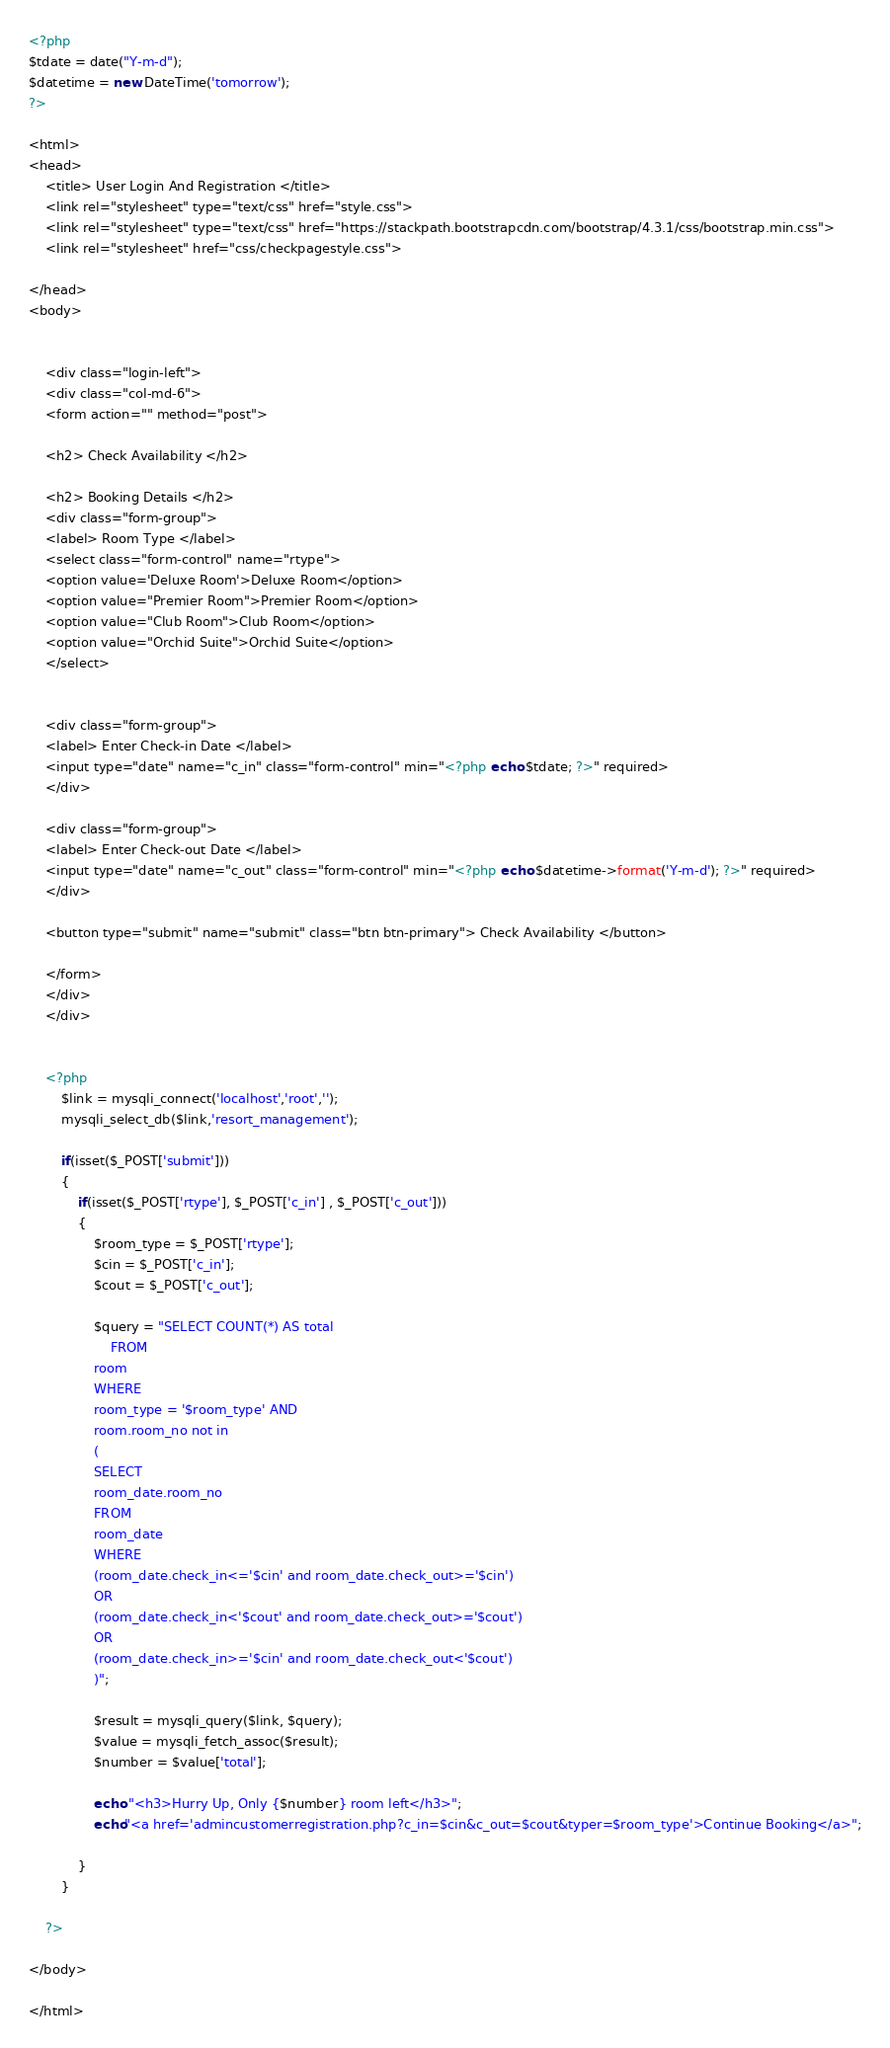<code> <loc_0><loc_0><loc_500><loc_500><_PHP_><?php
$tdate = date("Y-m-d");
$datetime = new DateTime('tomorrow');
?>

<html>
<head>
	<title> User Login And Registration </title>
	<link rel="stylesheet" type="text/css" href="style.css">
	<link rel="stylesheet" type="text/css" href="https://stackpath.bootstrapcdn.com/bootstrap/4.3.1/css/bootstrap.min.css">
	<link rel="stylesheet" href="css/checkpagestyle.css">

</head>
<body>


	<div class="login-left">
	<div class="col-md-6">
	<form action="" method="post">

	<h2> Check Availability </h2>

	<h2> Booking Details </h2>
	<div class="form-group">
	<label> Room Type </label>
	<select class="form-control" name="rtype">
	<option value='Deluxe Room'>Deluxe Room</option>
	<option value="Premier Room">Premier Room</option>
	<option value="Club Room">Club Room</option>
	<option value="Orchid Suite">Orchid Suite</option>
	</select>


	<div class="form-group">
	<label> Enter Check-in Date </label>
	<input type="date" name="c_in" class="form-control" min="<?php echo $tdate; ?>" required>
	</div>

	<div class="form-group">
	<label> Enter Check-out Date </label>
	<input type="date" name="c_out" class="form-control" min="<?php echo $datetime->format('Y-m-d'); ?>" required>
	</div>	

	<button type="submit" name="submit" class="btn btn-primary"> Check Availability </button>

	</form>
	</div>
	</div>


	<?php
		$link = mysqli_connect('localhost','root','');
		mysqli_select_db($link,'resort_management');

		if(isset($_POST['submit']))
		{
			if(isset($_POST['rtype'], $_POST['c_in'] , $_POST['c_out']))
			{
				$room_type = $_POST['rtype'];
				$cin = $_POST['c_in'];
				$cout = $_POST['c_out'];

				$query = "SELECT COUNT(*) AS total
					FROM
				room
				WHERE
				room_type = '$room_type' AND
				room.room_no not in 
				(
				SELECT
				room_date.room_no
				FROM
				room_date
				WHERE
				(room_date.check_in<='$cin' and room_date.check_out>='$cin')
				OR
				(room_date.check_in<'$cout' and room_date.check_out>='$cout')
				OR
				(room_date.check_in>='$cin' and room_date.check_out<'$cout')
				)";

				$result = mysqli_query($link, $query);
				$value = mysqli_fetch_assoc($result);
				$number = $value['total'];

				echo "<h3>Hurry Up, Only {$number} room left</h3>";
				echo"<a href='admincustomerregistration.php?c_in=$cin&c_out=$cout&typer=$room_type'>Continue Booking</a>";

			}
		}

	?>

</body>

</html></code> 